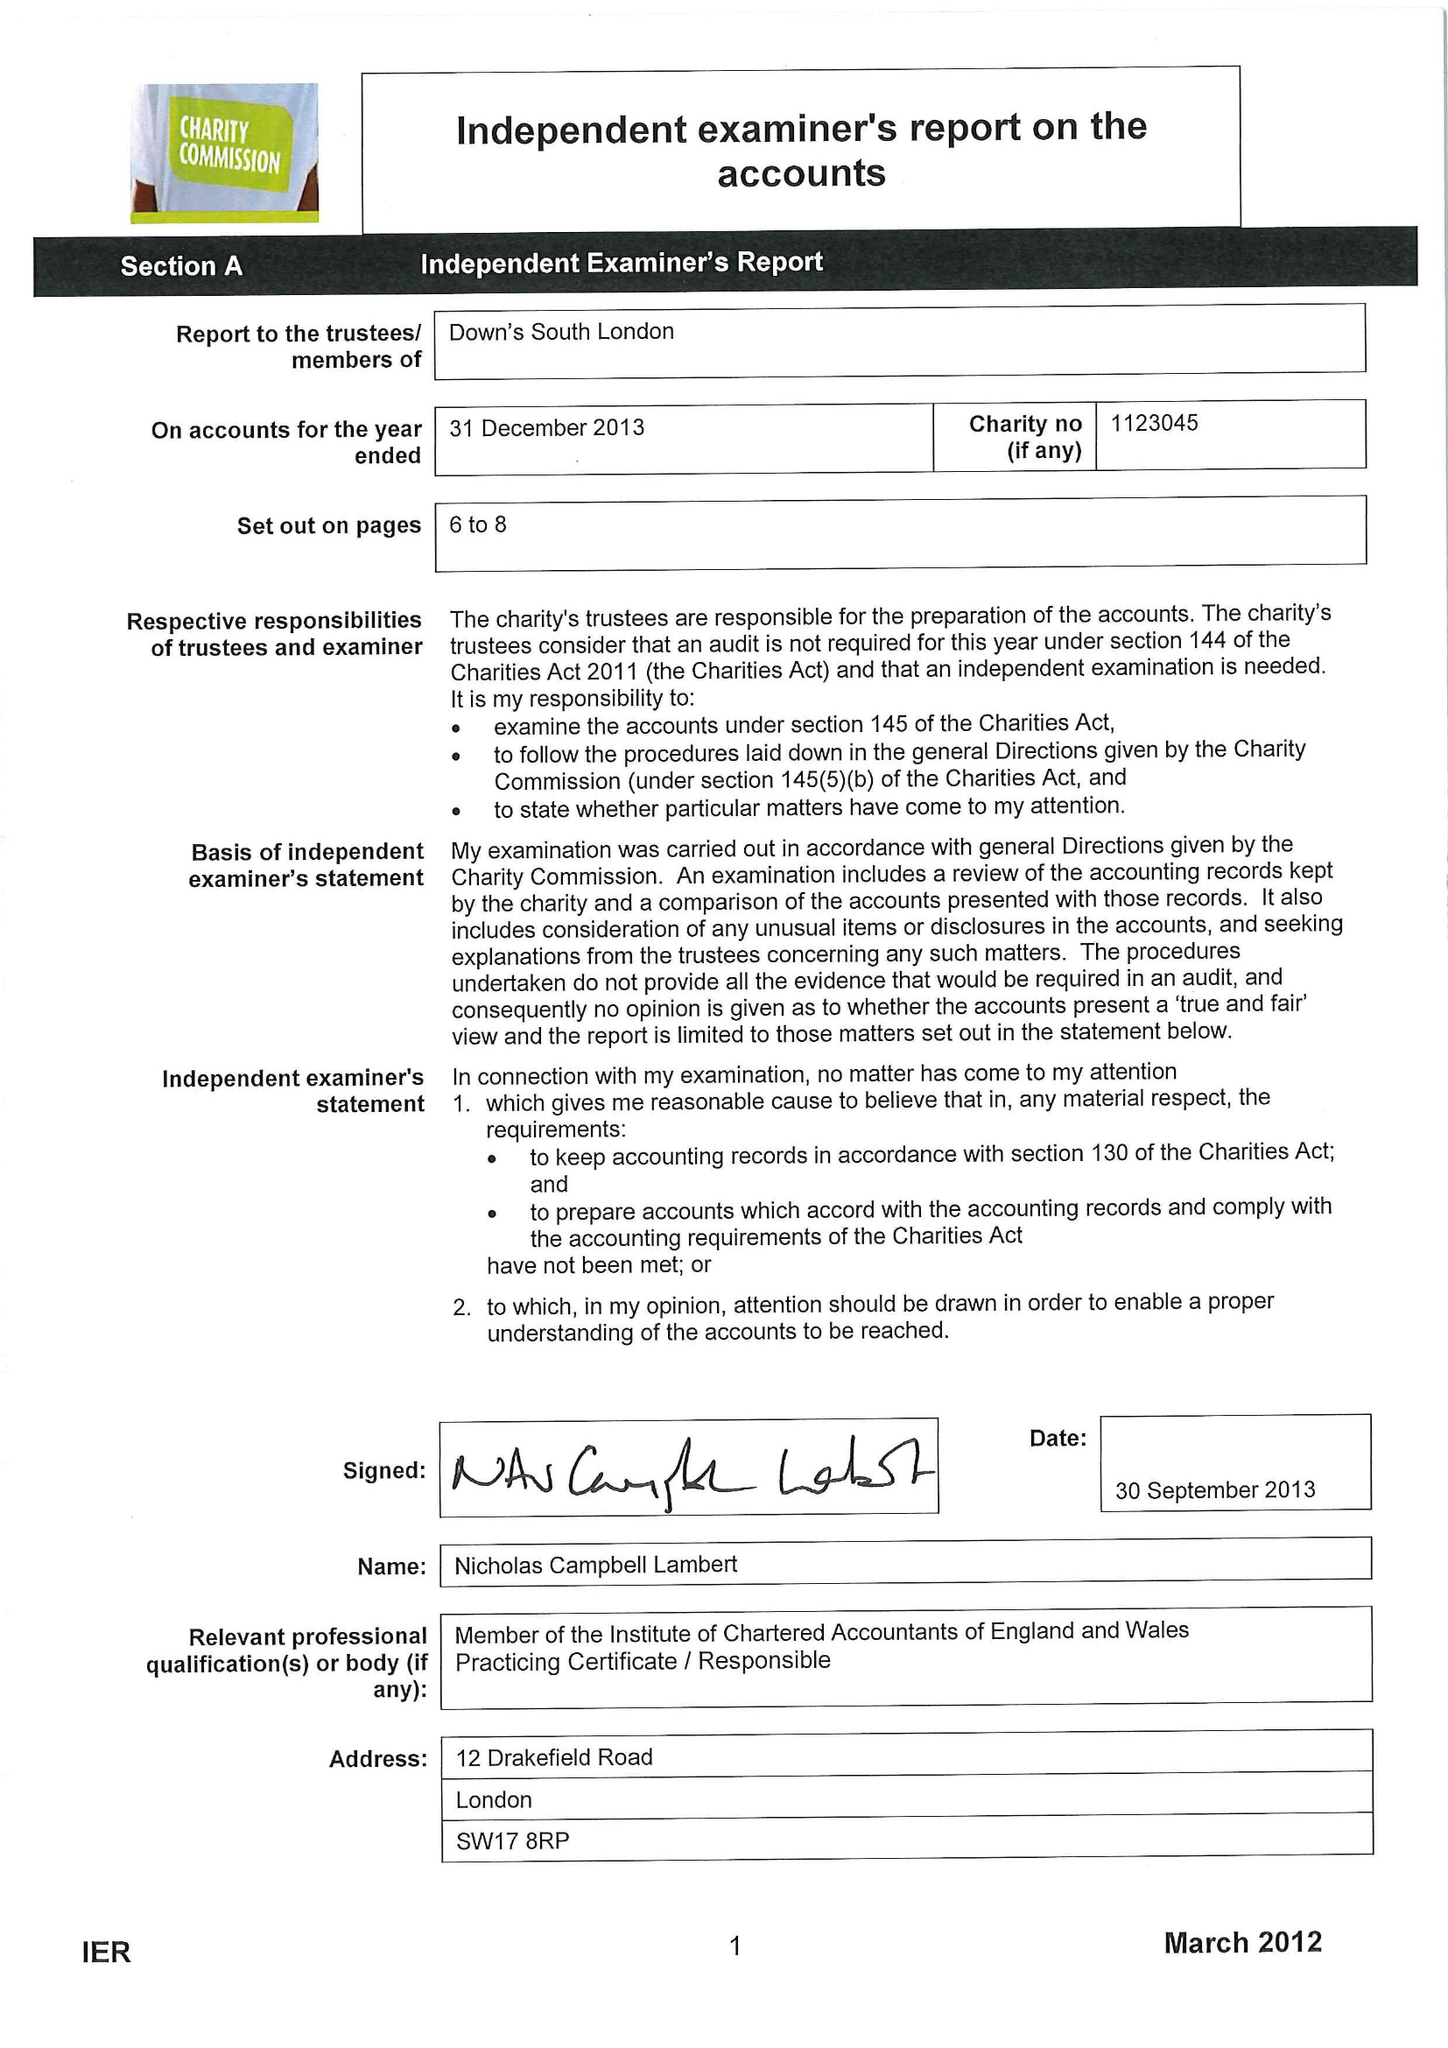What is the value for the address__postcode?
Answer the question using a single word or phrase. SE15 5AW 